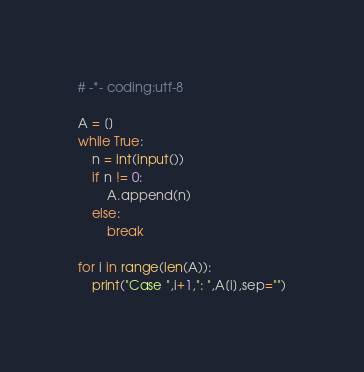<code> <loc_0><loc_0><loc_500><loc_500><_Python_># -*- coding:utf-8

A = []
while True:
    n = int(input())
    if n != 0:
        A.append(n)
    else:
        break

for i in range(len(A)):
    print("Case ",i+1,": ",A[i],sep="")
</code> 